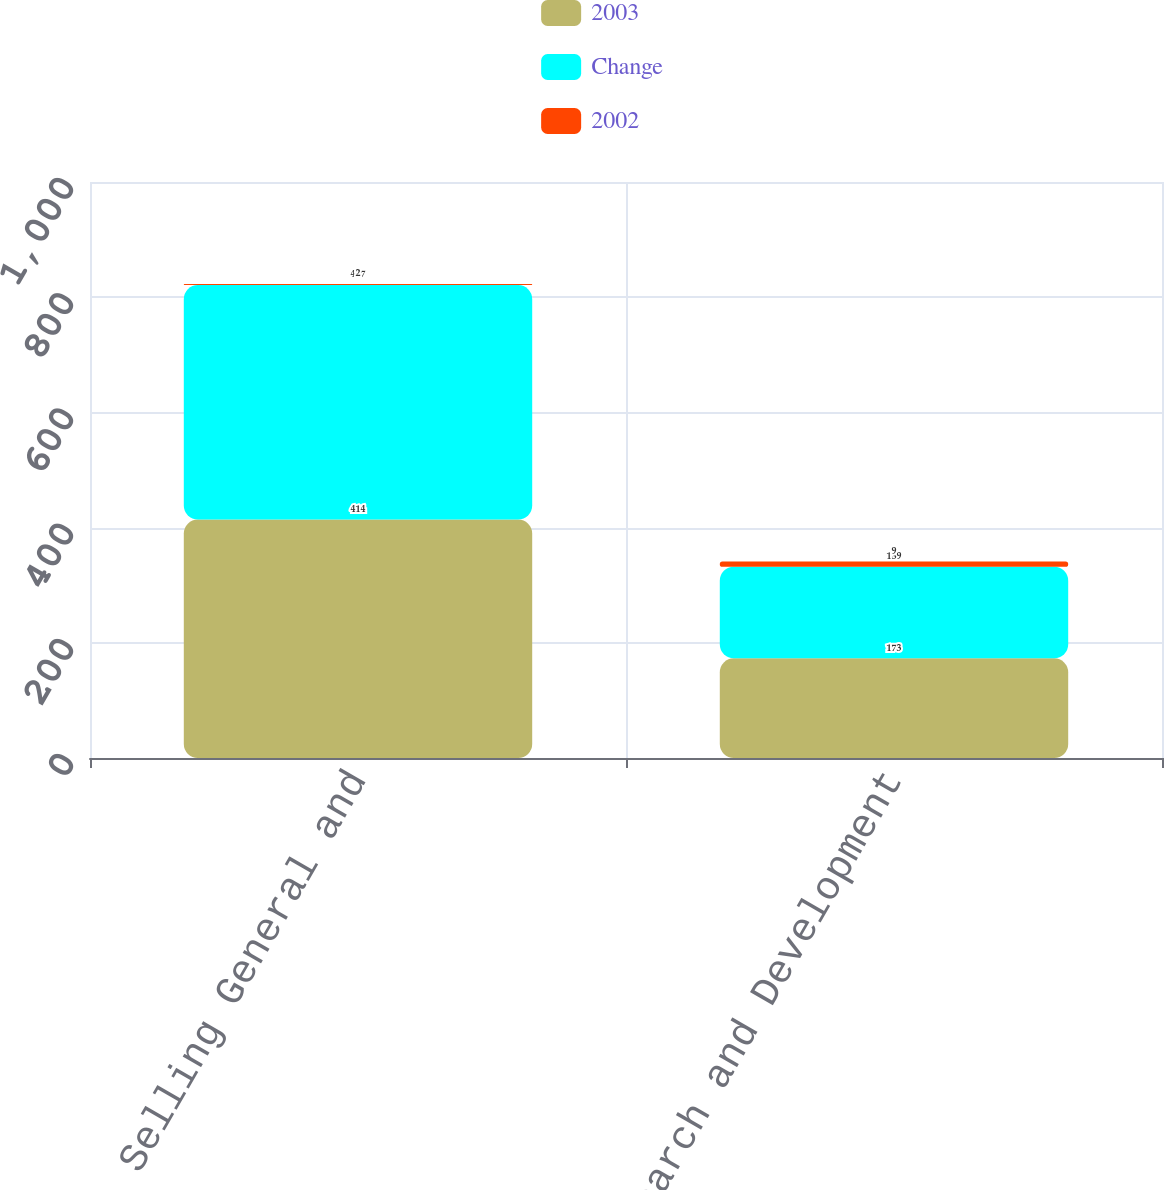Convert chart to OTSL. <chart><loc_0><loc_0><loc_500><loc_500><stacked_bar_chart><ecel><fcel>Selling General and<fcel>Research and Development<nl><fcel>2003<fcel>414<fcel>173<nl><fcel>Change<fcel>407<fcel>159<nl><fcel>2002<fcel>2<fcel>9<nl></chart> 